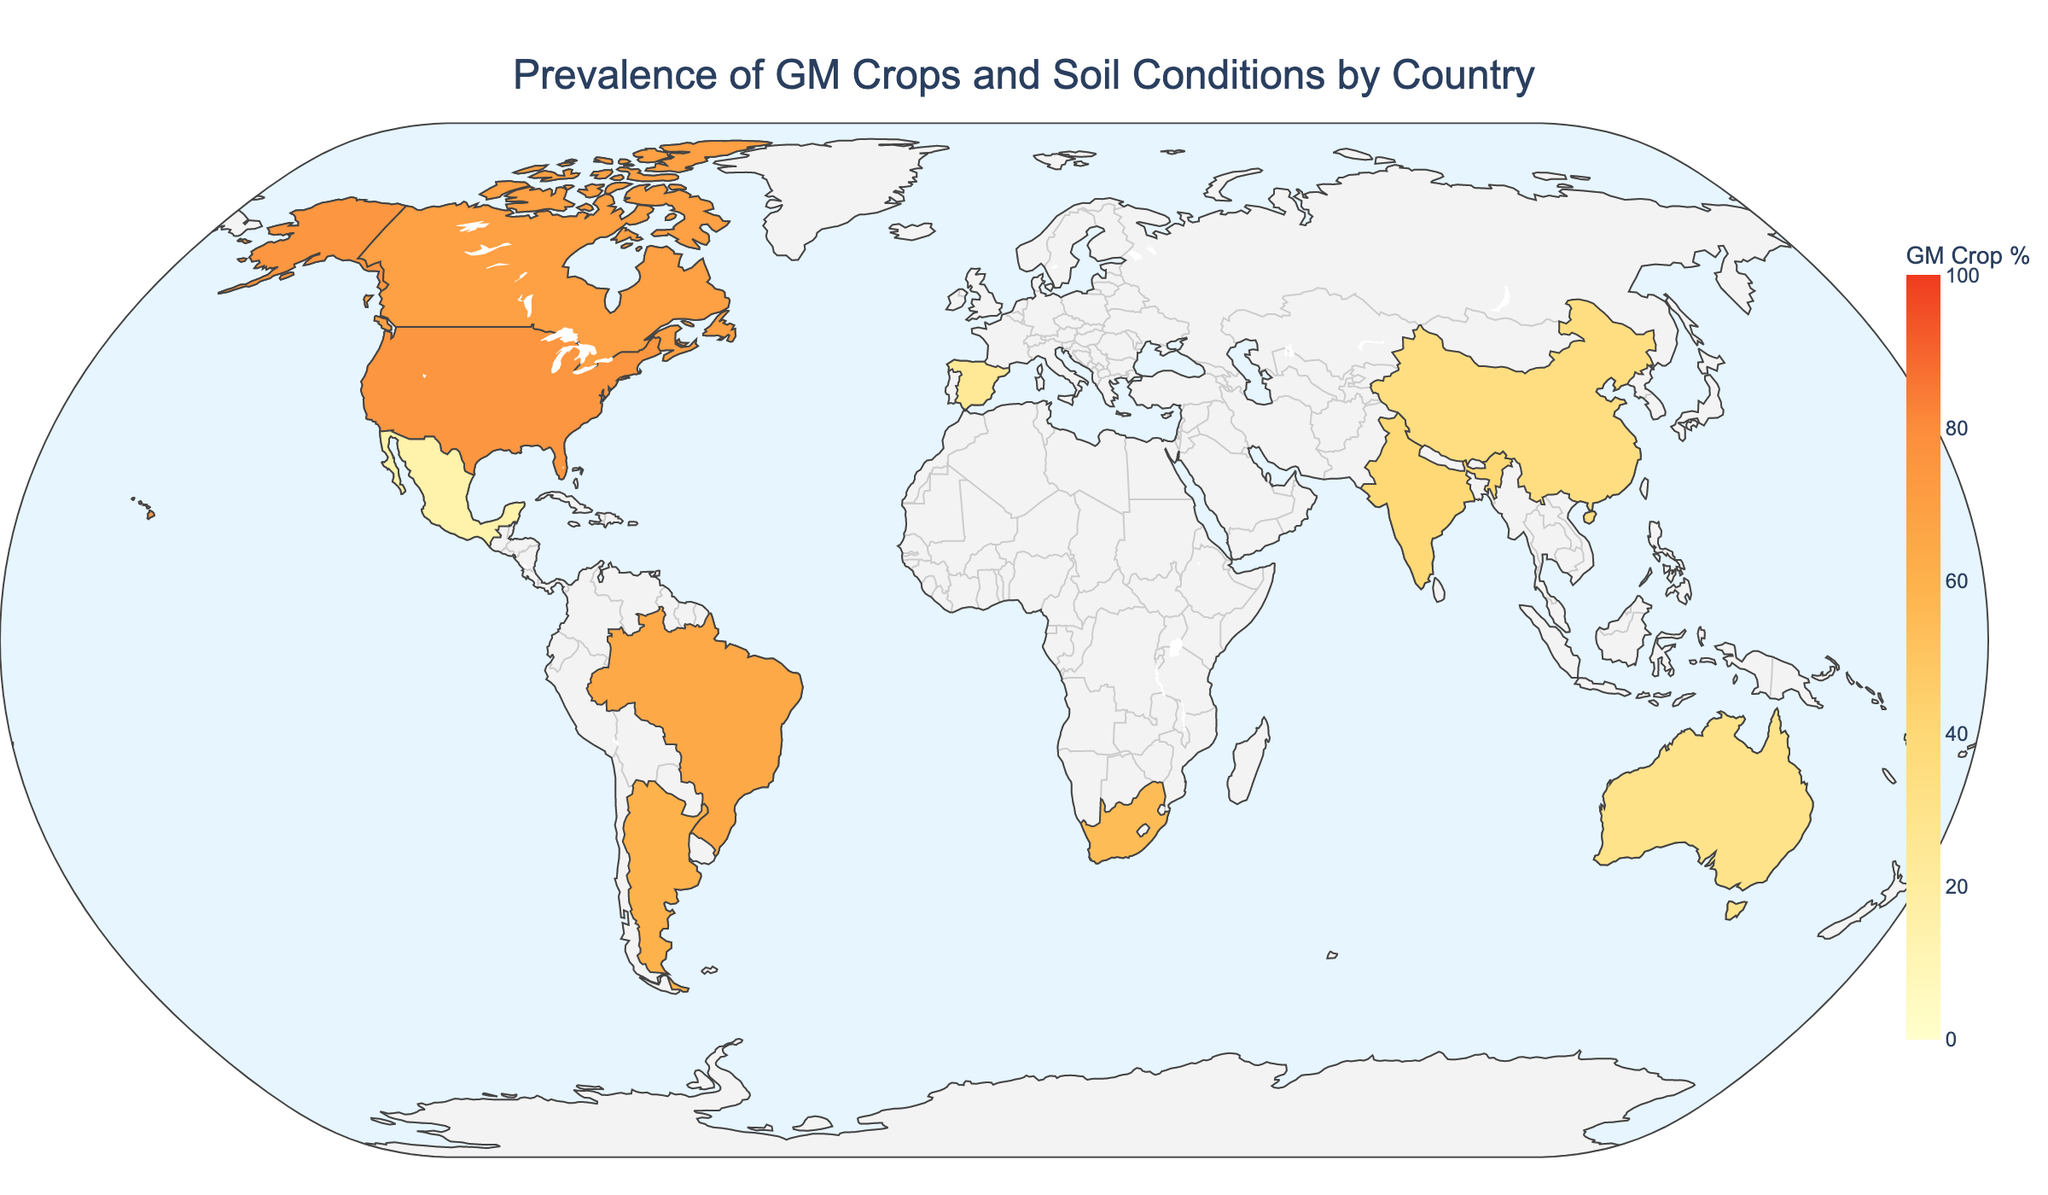What's the title of the map? The title can be found at the top of the map. It reads "Prevalence of GM Crops and Soil Conditions by Country"
Answer: Prevalence of GM Crops and Soil Conditions by Country Which country has the highest percentage of genetically modified (GM) crops? Look for the country with the highest value in the "GM Crop %" color scale or hover data. The United States is marked with the highest percentage, which is 75%.
Answer: United States What's the soil pH level in Brazil? Hover over Brazil on the map to see the detailed data. The soil pH value is provided in the hover data.
Answer: 5.8 How does Canada's GM crop percentage compare to Argentina's? Check both countries' values on the map. Canada has a GM Crop Percentage of 70%, while Argentina has 60%.
Answer: Canada has a higher GM crop percentage than Argentina Which country has the lowest correlation score between GM crop prevalence and soil conditions? Observe the hover data or text annotations added to the map for each country. Mexico has the lowest correlation score, which is 0.39.
Answer: Mexico Arrange the countries in descending order based on their clay content percentage. Extract clay content values from the hover data for each country and sort them: India (45%), Brazil (35%), China (30%), Mexico (28%), South Africa (25%), Argentina (22%), Spain (20%), United States (18%), Canada (15%), Australia (12%).
Answer: India, Brazil, China, Mexico, South Africa, Argentina, Spain, United States, Canada, Australia What is the average soil pH across all the countries shown? Sum the soil pH values and divide by the number of countries: (6.5 + 5.8 + 6.2 + 6.8 + 7.1 + 6.9 + 6.3 + 5.5 + 7.3 + 6.7) / 10 = 6.51
Answer: 6.51 How does the organic matter percentage in Canada compare to that in South Africa? Hover over Canada and South Africa to check their organic matter percentages. Canada has 3.5%, and South Africa has 1.5%.
Answer: Canada has a higher organic matter percentage than South Africa Which region shows a higher correlation between GM crop prevalence and soil conditions, North America or Asia? Identify the countries in North America (United States, Canada, Mexico) and Asia (India, China), compare the correlation scores, and average them for each region. North America: (0.82+0.85+0.39)/3≈0.69; Asia: (0.62+0.58)/2=0.60
Answer: North America has a higher average correlation score What is the range of GM crop percentages shown on the map? The minimum and maximum values of GM crop percentages on the map define the range. The lowest value is 15% (Mexico), and the highest is 75% (United States).
Answer: 15% to 75% 